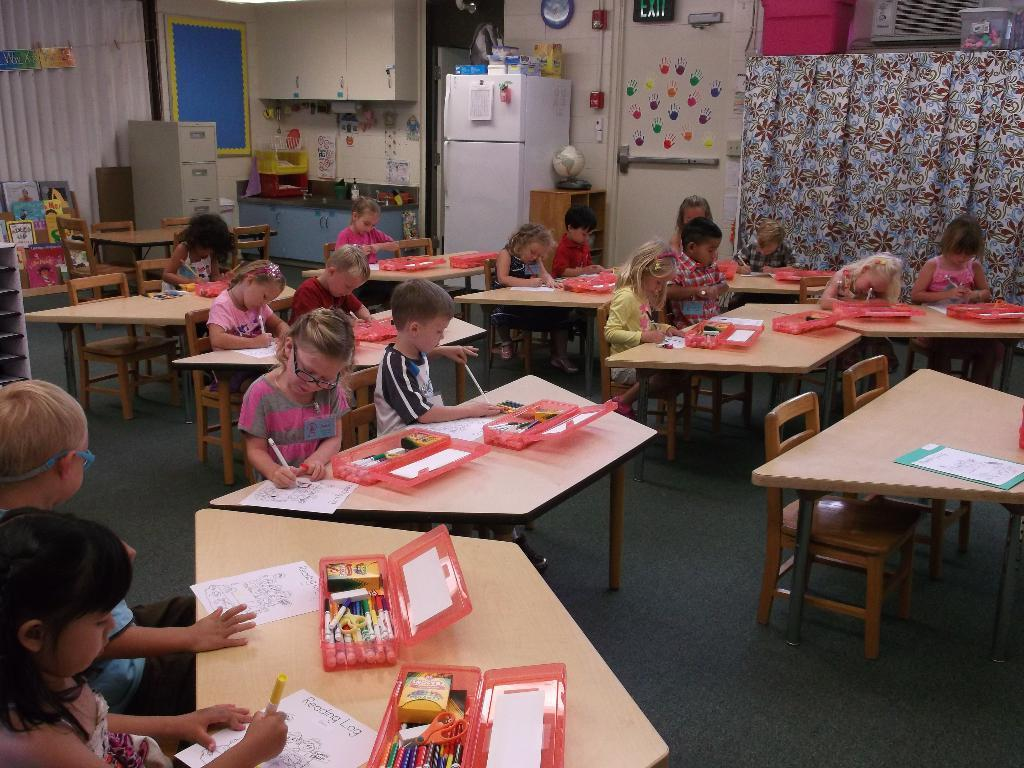Who is present in the image? There are children in the image. What are the children doing in the image? The children are sitting and coloring a picture on a paper. What can be seen in the background of the image? There is a refrigerator and a curtain in the image. What type of button is the child wearing on their shirt in the image? There is no button visible on the children's shirts in the image. How many daughters are present in the image? The term "daughter" is not mentioned in the provided facts, and there is no indication of gender for the children in the image. 